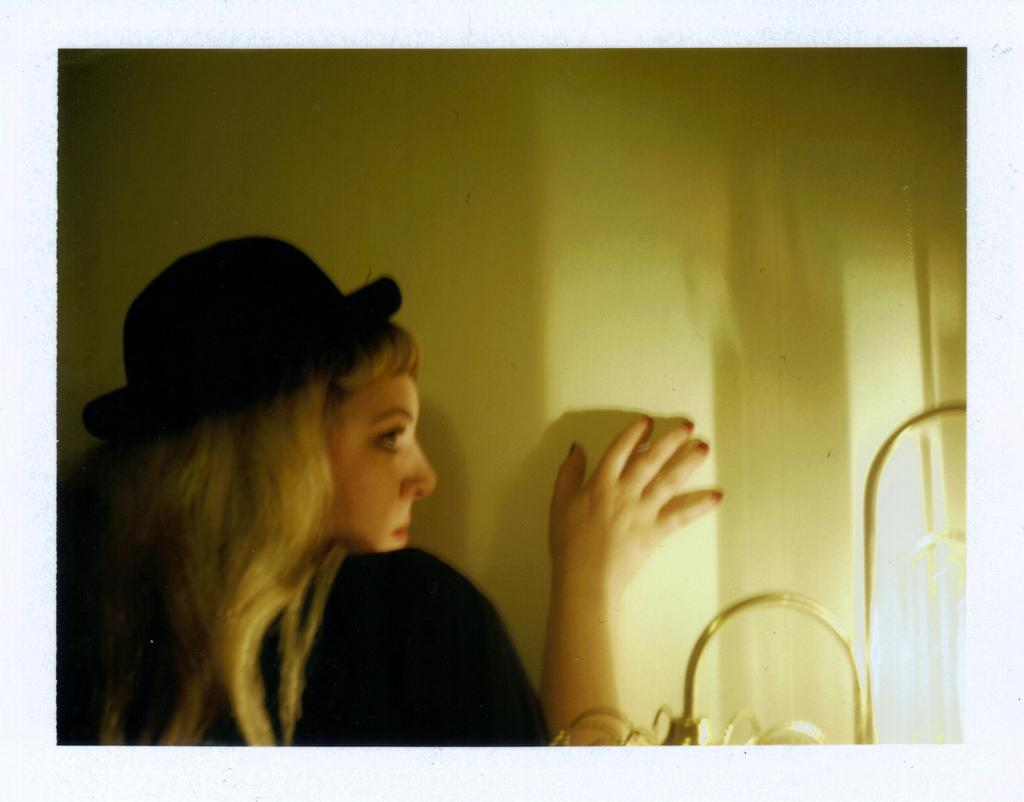Who is present in the image? There is a woman in the image. What is the woman wearing on her head? The woman is wearing a black hat. Where is the woman located in the image? The woman is standing near a wall. What can be seen in the image that provides illumination? There are lights visible in the image. How many oranges is the woman holding in the image? There are no oranges present in the image. What type of rings can be seen on the woman's fingers in the image? There are no rings visible on the woman's fingers in the image. 